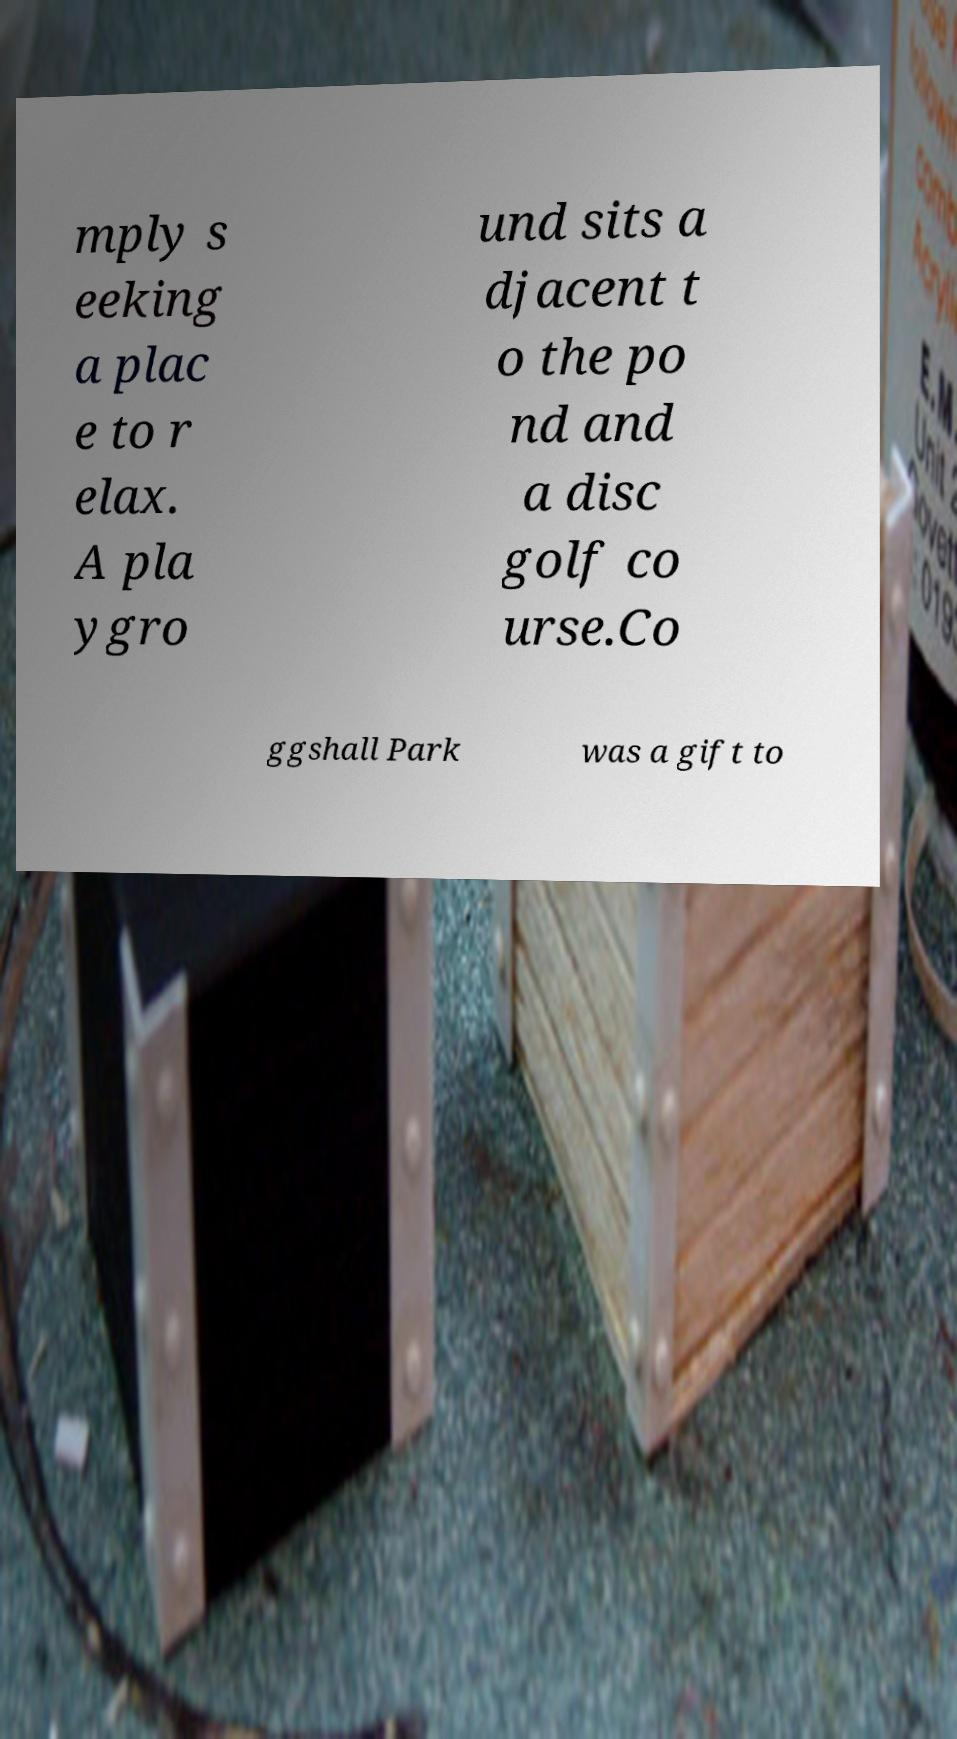Can you read and provide the text displayed in the image?This photo seems to have some interesting text. Can you extract and type it out for me? mply s eeking a plac e to r elax. A pla ygro und sits a djacent t o the po nd and a disc golf co urse.Co ggshall Park was a gift to 